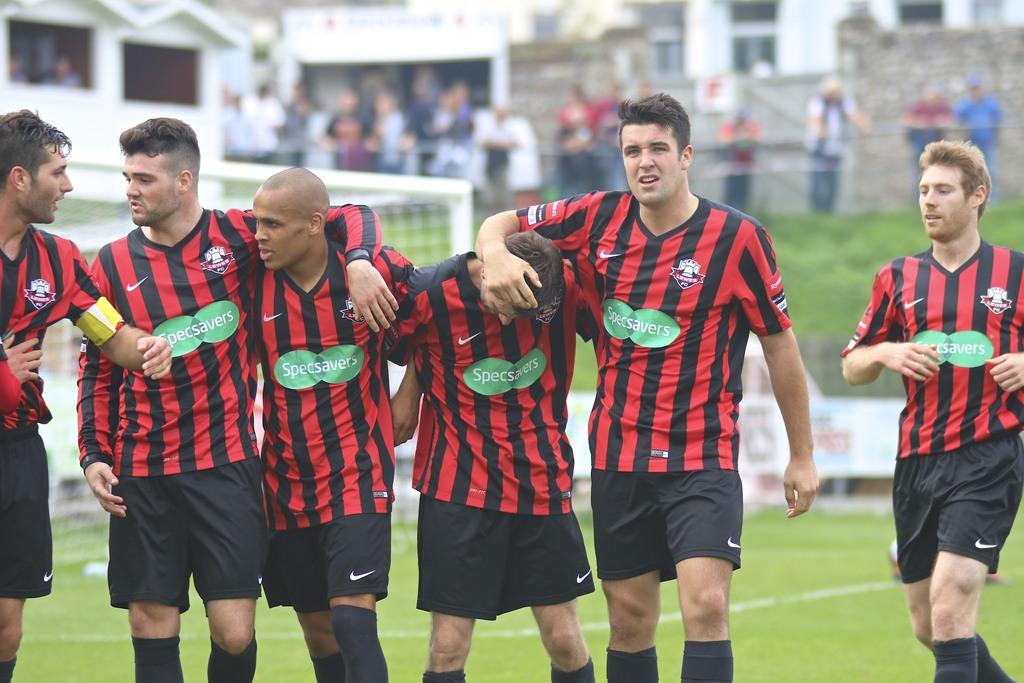Where is the image taken? The image is taken on the ground. What is happening in the middle of the image? There are 6 people in the middle of the image. What are the people in the middle wearing? All the people in the middle are wearing the same dresses. Are there any other people visible in the image? Yes, there are additional people at the top of the image. What type of toothpaste is being used by the people in the image? There is no toothpaste present in the image, as it features a group of people wearing dresses. Can you tell me the weight of the people in the image using a scale? There is no scale present in the image, and we cannot determine the weight of the people based on the provided information. 